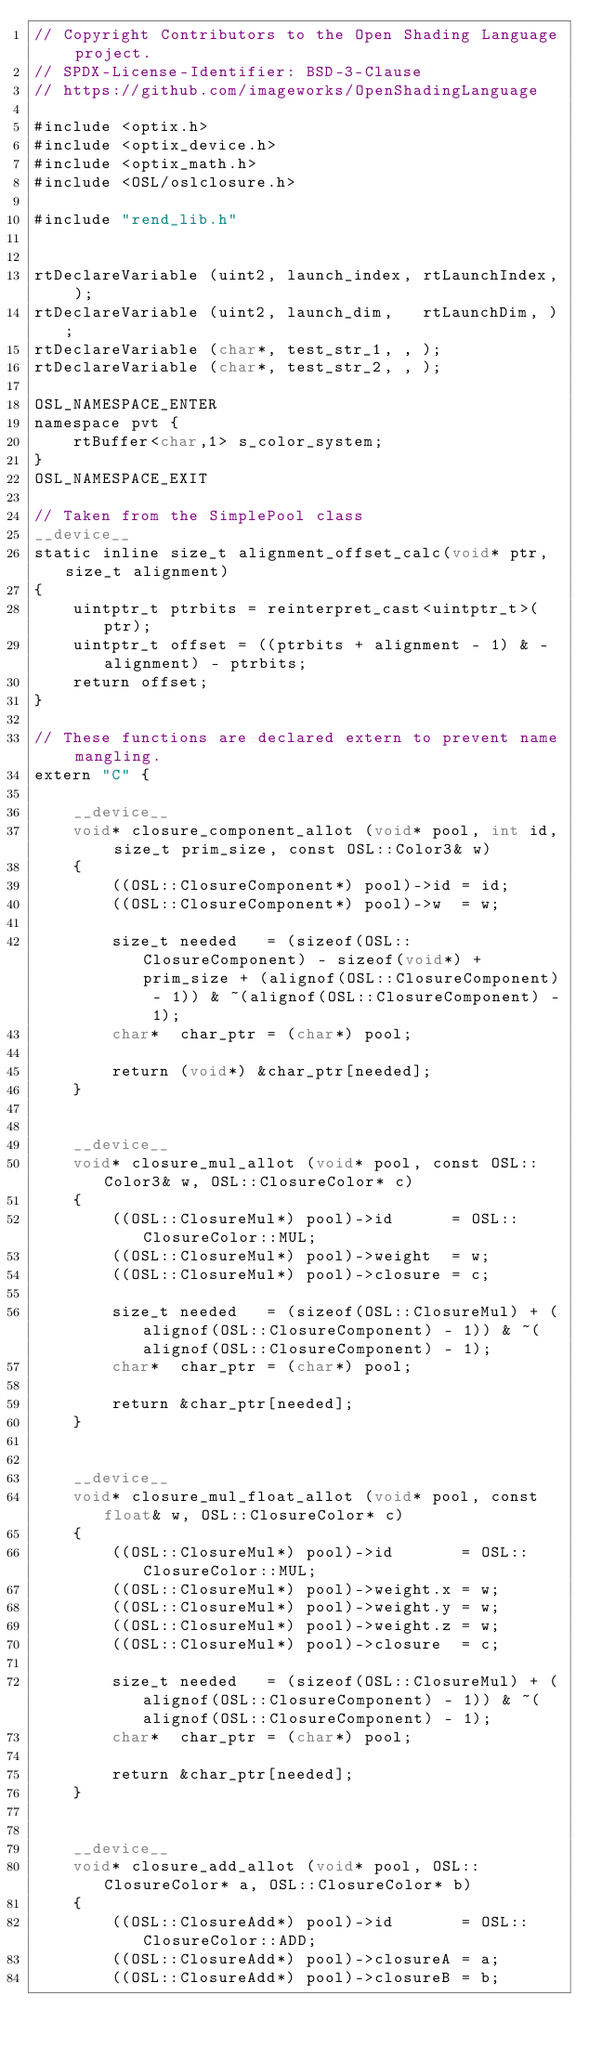<code> <loc_0><loc_0><loc_500><loc_500><_Cuda_>// Copyright Contributors to the Open Shading Language project.
// SPDX-License-Identifier: BSD-3-Clause
// https://github.com/imageworks/OpenShadingLanguage

#include <optix.h>
#include <optix_device.h>
#include <optix_math.h>
#include <OSL/oslclosure.h>

#include "rend_lib.h"


rtDeclareVariable (uint2, launch_index, rtLaunchIndex, );
rtDeclareVariable (uint2, launch_dim,   rtLaunchDim, );
rtDeclareVariable (char*, test_str_1, , );
rtDeclareVariable (char*, test_str_2, , );

OSL_NAMESPACE_ENTER
namespace pvt {
    rtBuffer<char,1> s_color_system;
}
OSL_NAMESPACE_EXIT

// Taken from the SimplePool class
__device__
static inline size_t alignment_offset_calc(void* ptr, size_t alignment)
{
    uintptr_t ptrbits = reinterpret_cast<uintptr_t>(ptr);
    uintptr_t offset = ((ptrbits + alignment - 1) & -alignment) - ptrbits;
    return offset;
}

// These functions are declared extern to prevent name mangling.
extern "C" {

    __device__
    void* closure_component_allot (void* pool, int id, size_t prim_size, const OSL::Color3& w)
    {
        ((OSL::ClosureComponent*) pool)->id = id;
        ((OSL::ClosureComponent*) pool)->w  = w;

        size_t needed   = (sizeof(OSL::ClosureComponent) - sizeof(void*) + prim_size + (alignof(OSL::ClosureComponent) - 1)) & ~(alignof(OSL::ClosureComponent) - 1);
        char*  char_ptr = (char*) pool;

        return (void*) &char_ptr[needed];
    }


    __device__
    void* closure_mul_allot (void* pool, const OSL::Color3& w, OSL::ClosureColor* c)
    {
        ((OSL::ClosureMul*) pool)->id      = OSL::ClosureColor::MUL;
        ((OSL::ClosureMul*) pool)->weight  = w;
        ((OSL::ClosureMul*) pool)->closure = c;

        size_t needed   = (sizeof(OSL::ClosureMul) + (alignof(OSL::ClosureComponent) - 1)) & ~(alignof(OSL::ClosureComponent) - 1);
        char*  char_ptr = (char*) pool;

        return &char_ptr[needed];
    }


    __device__
    void* closure_mul_float_allot (void* pool, const float& w, OSL::ClosureColor* c)
    {
        ((OSL::ClosureMul*) pool)->id       = OSL::ClosureColor::MUL;
        ((OSL::ClosureMul*) pool)->weight.x = w;
        ((OSL::ClosureMul*) pool)->weight.y = w;
        ((OSL::ClosureMul*) pool)->weight.z = w;
        ((OSL::ClosureMul*) pool)->closure  = c;

        size_t needed   = (sizeof(OSL::ClosureMul) + (alignof(OSL::ClosureComponent) - 1)) & ~(alignof(OSL::ClosureComponent) - 1);
        char*  char_ptr = (char*) pool;

        return &char_ptr[needed];
    }


    __device__
    void* closure_add_allot (void* pool, OSL::ClosureColor* a, OSL::ClosureColor* b)
    {
        ((OSL::ClosureAdd*) pool)->id       = OSL::ClosureColor::ADD;
        ((OSL::ClosureAdd*) pool)->closureA = a;
        ((OSL::ClosureAdd*) pool)->closureB = b;
</code> 